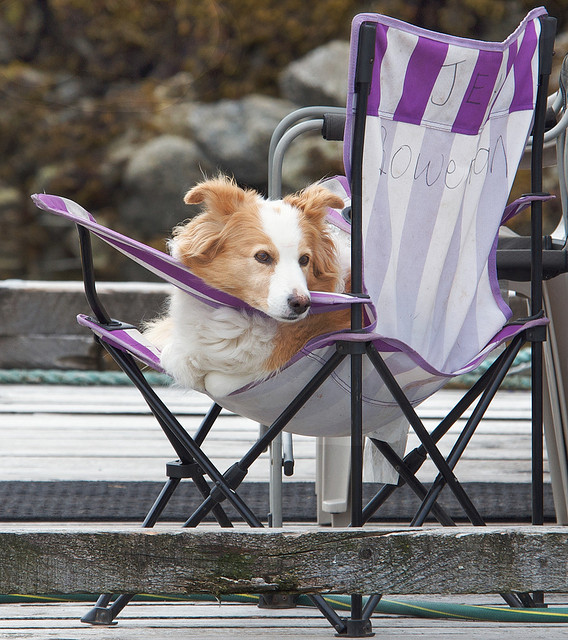Read and extract the text from this image. JE 